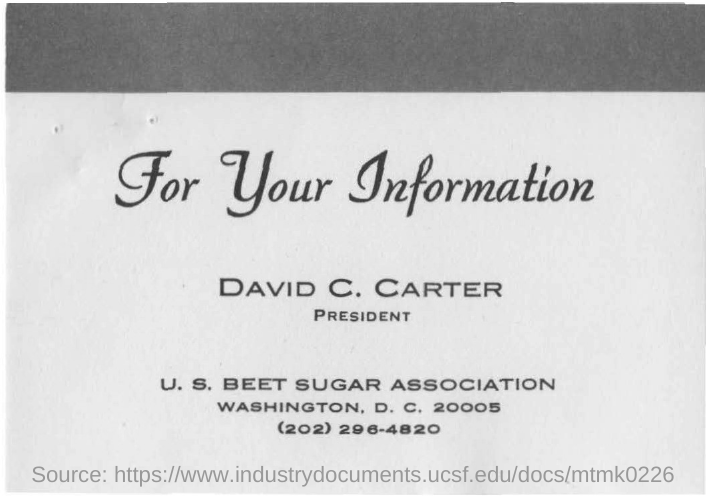List a handful of essential elements in this visual. I declare that the president's name is David C. Carter. The phone number of the U.S. BEET SUGAR ASSOCIATION is (202) 296-4820. 